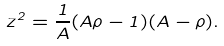Convert formula to latex. <formula><loc_0><loc_0><loc_500><loc_500>z ^ { 2 } = \frac { 1 } { A } ( A \rho - 1 ) ( A - \rho ) .</formula> 